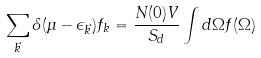Convert formula to latex. <formula><loc_0><loc_0><loc_500><loc_500>\sum _ { \vec { k } } \delta ( \mu - \epsilon _ { \vec { k } } ) f _ { k } = \frac { N ( 0 ) V } { S _ { d } } \int d \Omega f ( \Omega )</formula> 